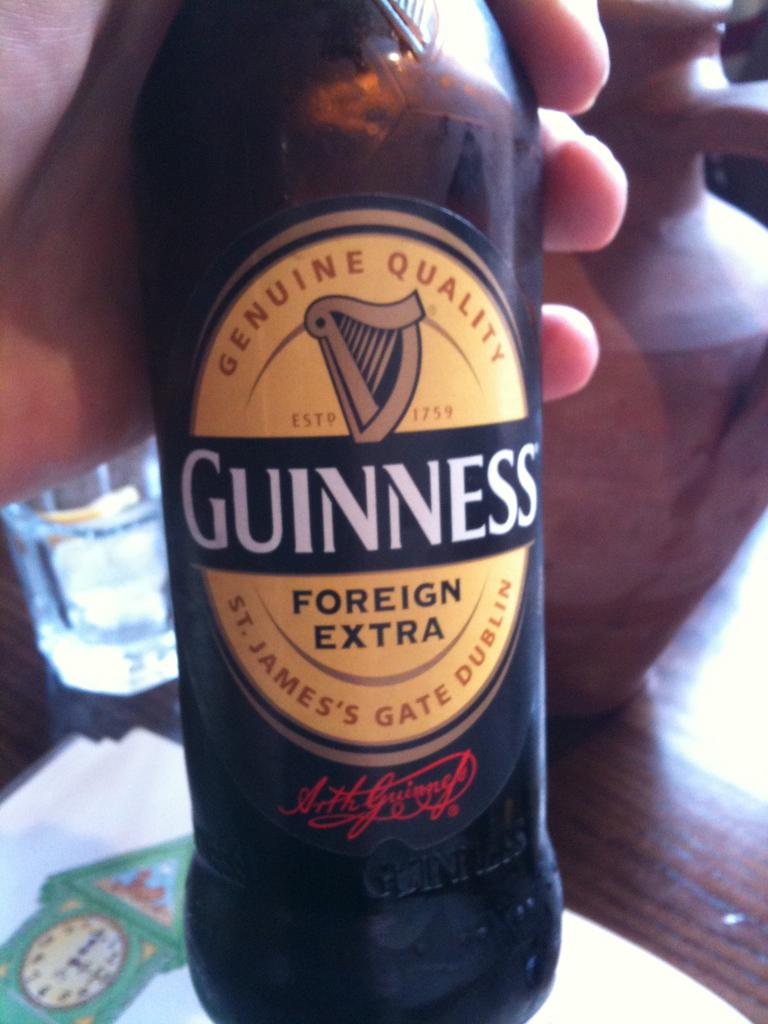Provide a one-sentence caption for the provided image. A genuine bottle of Foreign Extra Guinness beer. 